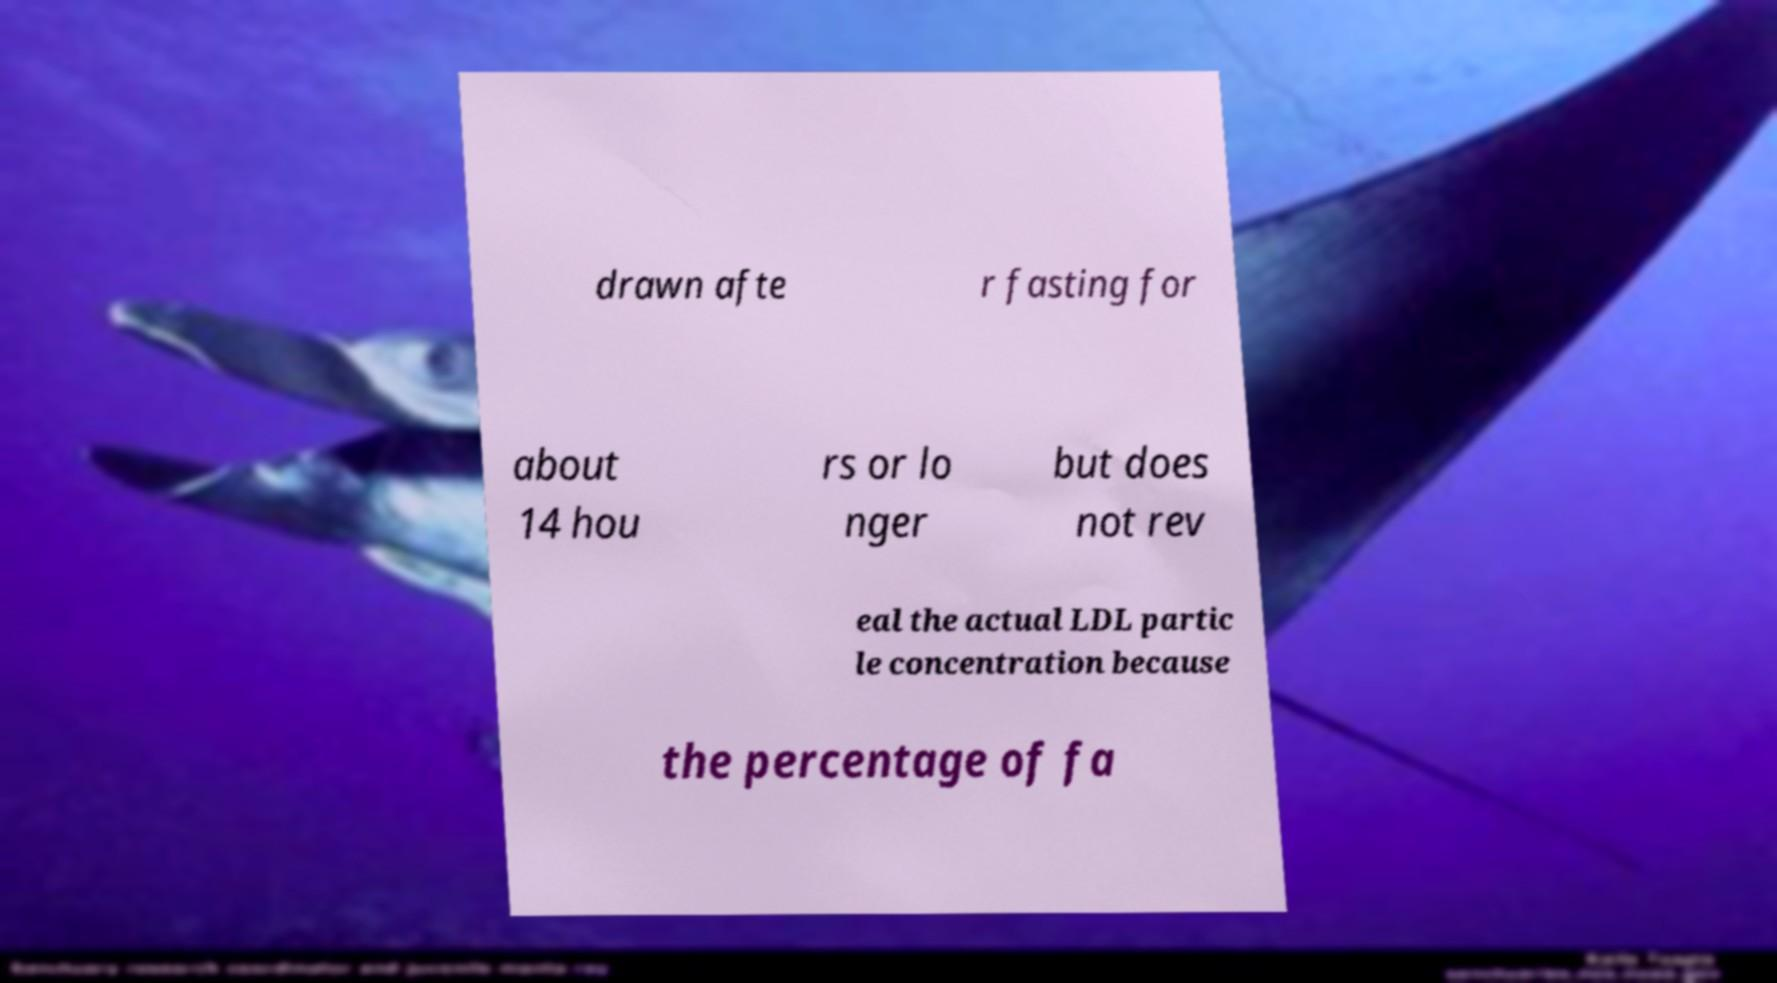Can you accurately transcribe the text from the provided image for me? drawn afte r fasting for about 14 hou rs or lo nger but does not rev eal the actual LDL partic le concentration because the percentage of fa 